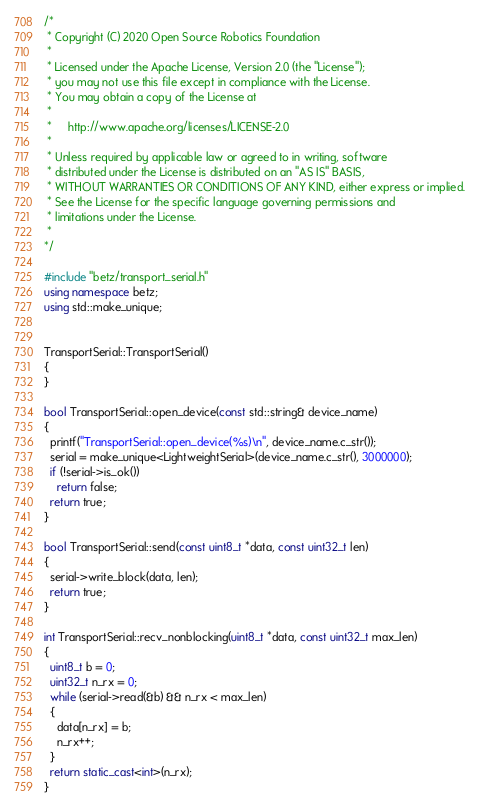Convert code to text. <code><loc_0><loc_0><loc_500><loc_500><_C++_>/*
 * Copyright (C) 2020 Open Source Robotics Foundation
 *
 * Licensed under the Apache License, Version 2.0 (the "License");
 * you may not use this file except in compliance with the License.
 * You may obtain a copy of the License at
 *
 *     http://www.apache.org/licenses/LICENSE-2.0
 *
 * Unless required by applicable law or agreed to in writing, software
 * distributed under the License is distributed on an "AS IS" BASIS,
 * WITHOUT WARRANTIES OR CONDITIONS OF ANY KIND, either express or implied.
 * See the License for the specific language governing permissions and
 * limitations under the License.
 *
*/

#include "betz/transport_serial.h"
using namespace betz;
using std::make_unique;


TransportSerial::TransportSerial()
{
}

bool TransportSerial::open_device(const std::string& device_name)
{
  printf("TransportSerial::open_device(%s)\n", device_name.c_str());
  serial = make_unique<LightweightSerial>(device_name.c_str(), 3000000);
  if (!serial->is_ok())
    return false;
  return true;
}

bool TransportSerial::send(const uint8_t *data, const uint32_t len)
{
  serial->write_block(data, len);
  return true;
}

int TransportSerial::recv_nonblocking(uint8_t *data, const uint32_t max_len)
{
  uint8_t b = 0;
  uint32_t n_rx = 0;
  while (serial->read(&b) && n_rx < max_len)
  {
    data[n_rx] = b;
    n_rx++;
  }
  return static_cast<int>(n_rx);
}
</code> 